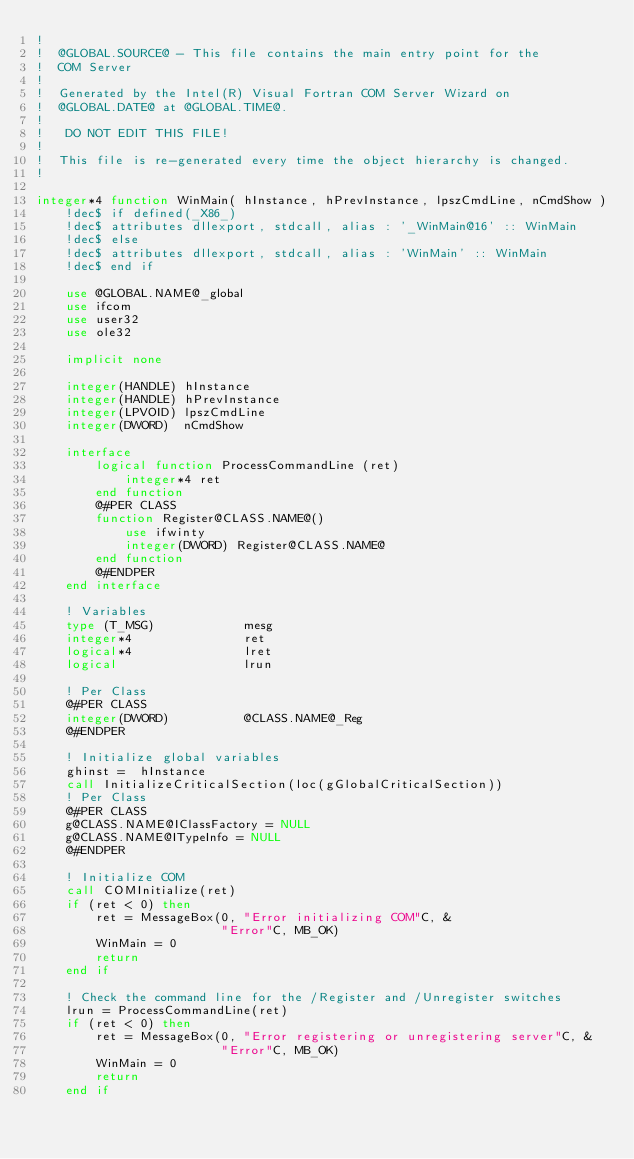Convert code to text. <code><loc_0><loc_0><loc_500><loc_500><_FORTRAN_>!
!  @GLOBAL.SOURCE@ - This file contains the main entry point for the
!  COM Server
!
!  Generated by the Intel(R) Visual Fortran COM Server Wizard on
!  @GLOBAL.DATE@ at @GLOBAL.TIME@.
!
!   DO NOT EDIT THIS FILE!
!
!  This file is re-generated every time the object hierarchy is changed.
!

integer*4 function WinMain( hInstance, hPrevInstance, lpszCmdLine, nCmdShow )
    !dec$ if defined(_X86_)
    !dec$ attributes dllexport, stdcall, alias : '_WinMain@16' :: WinMain
    !dec$ else
    !dec$ attributes dllexport, stdcall, alias : 'WinMain' :: WinMain
    !dec$ end if

    use @GLOBAL.NAME@_global
    use ifcom
    use user32
    use ole32

    implicit none

    integer(HANDLE) hInstance
    integer(HANDLE) hPrevInstance
    integer(LPVOID) lpszCmdLine
    integer(DWORD)  nCmdShow

    interface
        logical function ProcessCommandLine (ret)
            integer*4 ret
        end function
        @#PER CLASS
        function Register@CLASS.NAME@()
            use ifwinty
            integer(DWORD) Register@CLASS.NAME@
        end function
        @#ENDPER
    end interface

    ! Variables
    type (T_MSG)            mesg
    integer*4               ret
    logical*4               lret
    logical                 lrun

    ! Per Class
    @#PER CLASS
    integer(DWORD)          @CLASS.NAME@_Reg
    @#ENDPER

    ! Initialize global variables
    ghinst =  hInstance
    call InitializeCriticalSection(loc(gGlobalCriticalSection))
    ! Per Class
    @#PER CLASS
    g@CLASS.NAME@IClassFactory = NULL
    g@CLASS.NAME@ITypeInfo = NULL
    @#ENDPER

    ! Initialize COM
    call COMInitialize(ret)
    if (ret < 0) then
        ret = MessageBox(0, "Error initializing COM"C, &
                         "Error"C, MB_OK)
        WinMain = 0
        return
    end if
                           
    ! Check the command line for the /Register and /Unregister switches
    lrun = ProcessCommandLine(ret)
    if (ret < 0) then
        ret = MessageBox(0, "Error registering or unregistering server"C, &
                         "Error"C, MB_OK)
        WinMain = 0
        return
    end if
</code> 